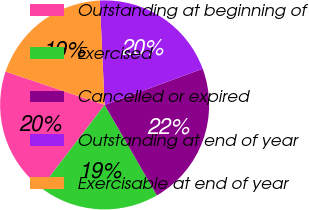Convert chart. <chart><loc_0><loc_0><loc_500><loc_500><pie_chart><fcel>Outstanding at beginning of<fcel>Exercised<fcel>Cancelled or expired<fcel>Outstanding at end of year<fcel>Exercisable at end of year<nl><fcel>19.76%<fcel>18.74%<fcel>22.29%<fcel>20.11%<fcel>19.1%<nl></chart> 